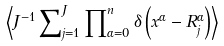<formula> <loc_0><loc_0><loc_500><loc_500>\left \langle J ^ { - 1 } \sum \nolimits _ { j = 1 } ^ { J } \prod \nolimits _ { \alpha = 0 } ^ { n } \delta \left ( { x } ^ { \alpha } - { R } _ { j } ^ { \alpha } \right ) \right \rangle</formula> 